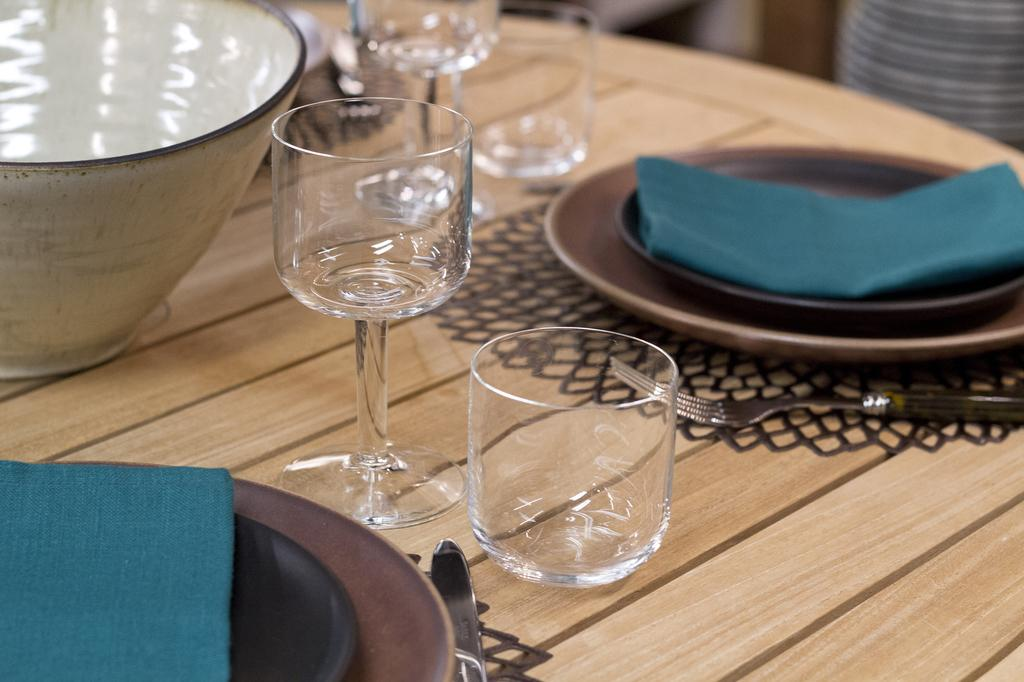What type of tableware can be seen in the image? There are glasses, plates, and a fork in the image. What else is present in the image besides tableware? There are clothes and a bowl in the image. What type of cabbage is being used as a tablecloth in the image? There is no cabbage present in the image, nor is it being used as a tablecloth. 